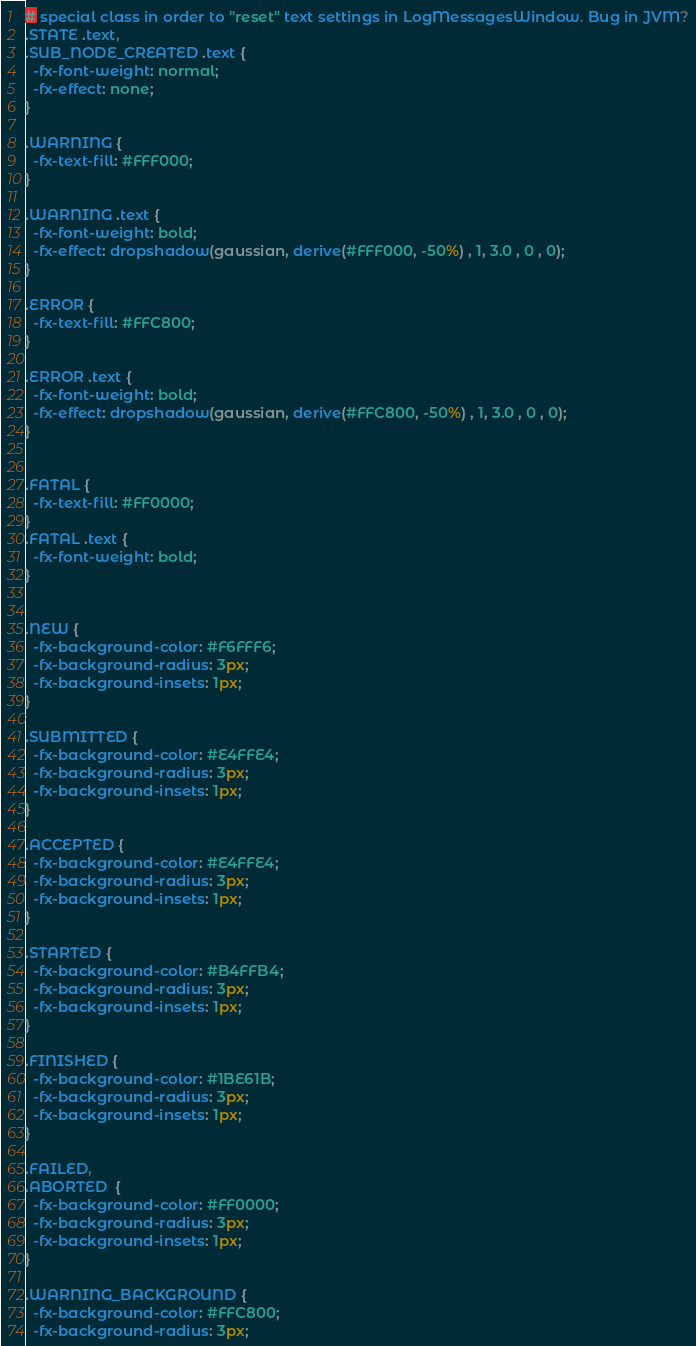Convert code to text. <code><loc_0><loc_0><loc_500><loc_500><_CSS_># special class in order to "reset" text settings in LogMessagesWindow. Bug in JVM?
.STATE .text,
.SUB_NODE_CREATED .text {
  -fx-font-weight: normal;
  -fx-effect: none;
}

.WARNING {
  -fx-text-fill: #FFF000;
}

.WARNING .text {
  -fx-font-weight: bold;
  -fx-effect: dropshadow(gaussian, derive(#FFF000, -50%) , 1, 3.0 , 0 , 0);
}

.ERROR {
  -fx-text-fill: #FFC800;
}

.ERROR .text {
  -fx-font-weight: bold;
  -fx-effect: dropshadow(gaussian, derive(#FFC800, -50%) , 1, 3.0 , 0 , 0);
}


.FATAL {
  -fx-text-fill: #FF0000;
}
.FATAL .text {
  -fx-font-weight: bold;
}


.NEW {
  -fx-background-color: #F6FFF6;
  -fx-background-radius: 3px;
  -fx-background-insets: 1px;
}

.SUBMITTED {
  -fx-background-color: #E4FFE4;
  -fx-background-radius: 3px;
  -fx-background-insets: 1px;
}

.ACCEPTED {
  -fx-background-color: #E4FFE4;
  -fx-background-radius: 3px;
  -fx-background-insets: 1px;
}

.STARTED {
  -fx-background-color: #B4FFB4;
  -fx-background-radius: 3px;
  -fx-background-insets: 1px;
}

.FINISHED {
  -fx-background-color: #1BE61B;
  -fx-background-radius: 3px;
  -fx-background-insets: 1px;
}

.FAILED,
.ABORTED  {
  -fx-background-color: #FF0000;
  -fx-background-radius: 3px;
  -fx-background-insets: 1px;
}

.WARNING_BACKGROUND {
  -fx-background-color: #FFC800;
  -fx-background-radius: 3px;</code> 